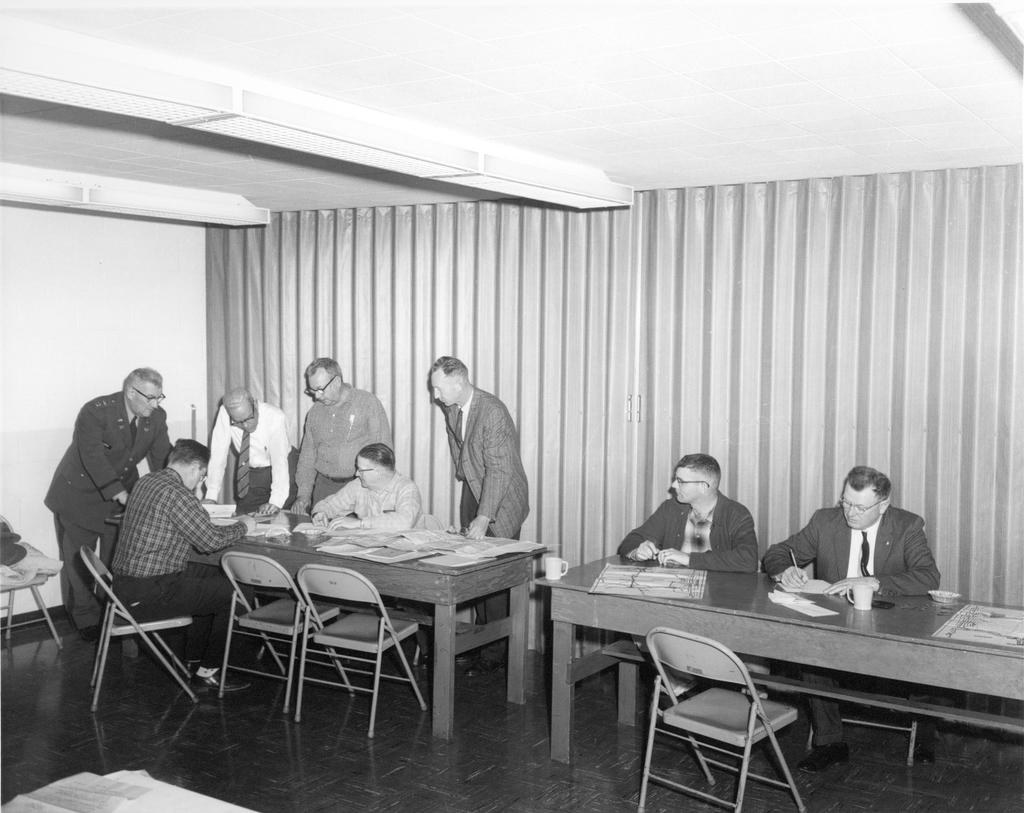How many people are in the image? There is a group of persons in the image. What are the people in the image doing? The persons are doing some work. Can you describe the positions of the people in the image? Some of the persons are sitting on a table, while some are standing on the floor. What type of feather can be seen floating in the air in the image? There is no feather present in the image; it only features a group of persons working. 